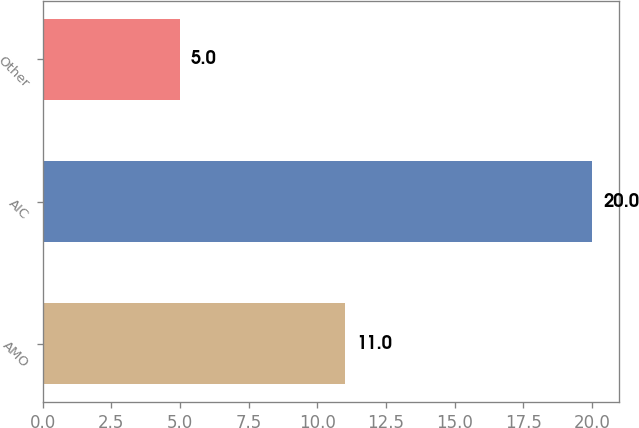Convert chart to OTSL. <chart><loc_0><loc_0><loc_500><loc_500><bar_chart><fcel>AMO<fcel>AIC<fcel>Other<nl><fcel>11<fcel>20<fcel>5<nl></chart> 